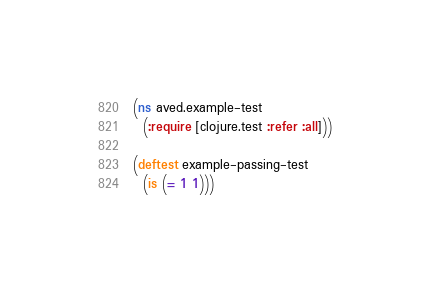<code> <loc_0><loc_0><loc_500><loc_500><_Clojure_>(ns aved.example-test
  (:require [clojure.test :refer :all]))

(deftest example-passing-test
  (is (= 1 1)))
</code> 